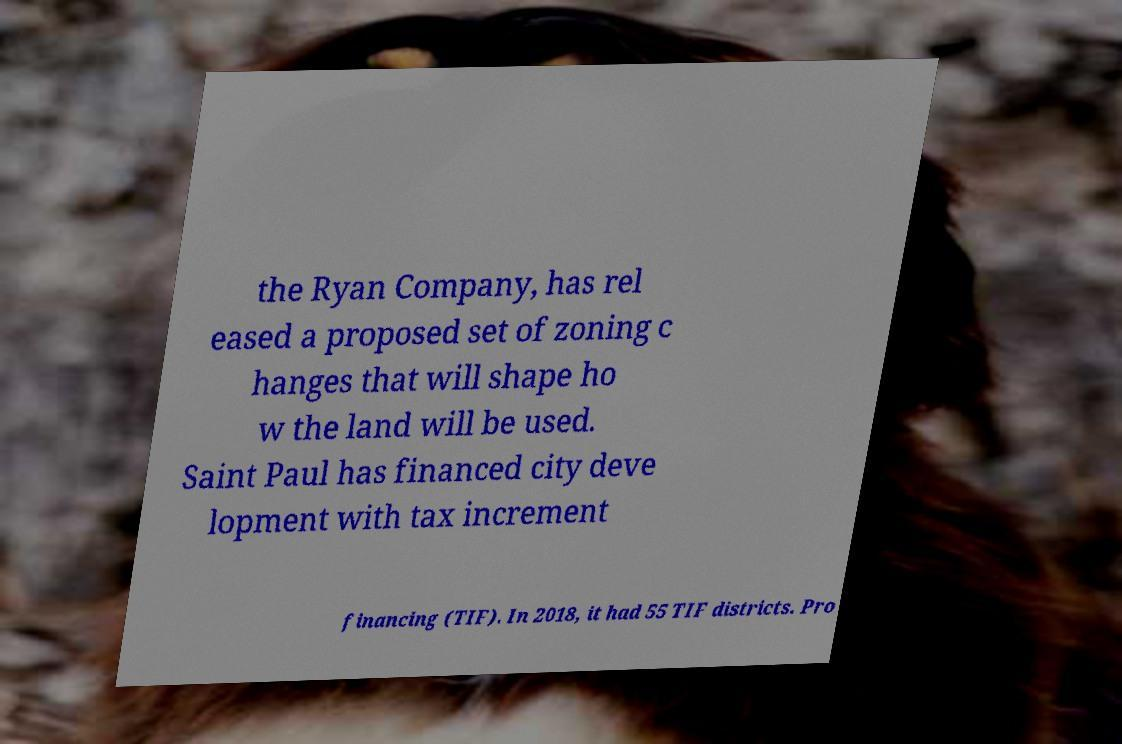Please read and relay the text visible in this image. What does it say? the Ryan Company, has rel eased a proposed set of zoning c hanges that will shape ho w the land will be used. Saint Paul has financed city deve lopment with tax increment financing (TIF). In 2018, it had 55 TIF districts. Pro 